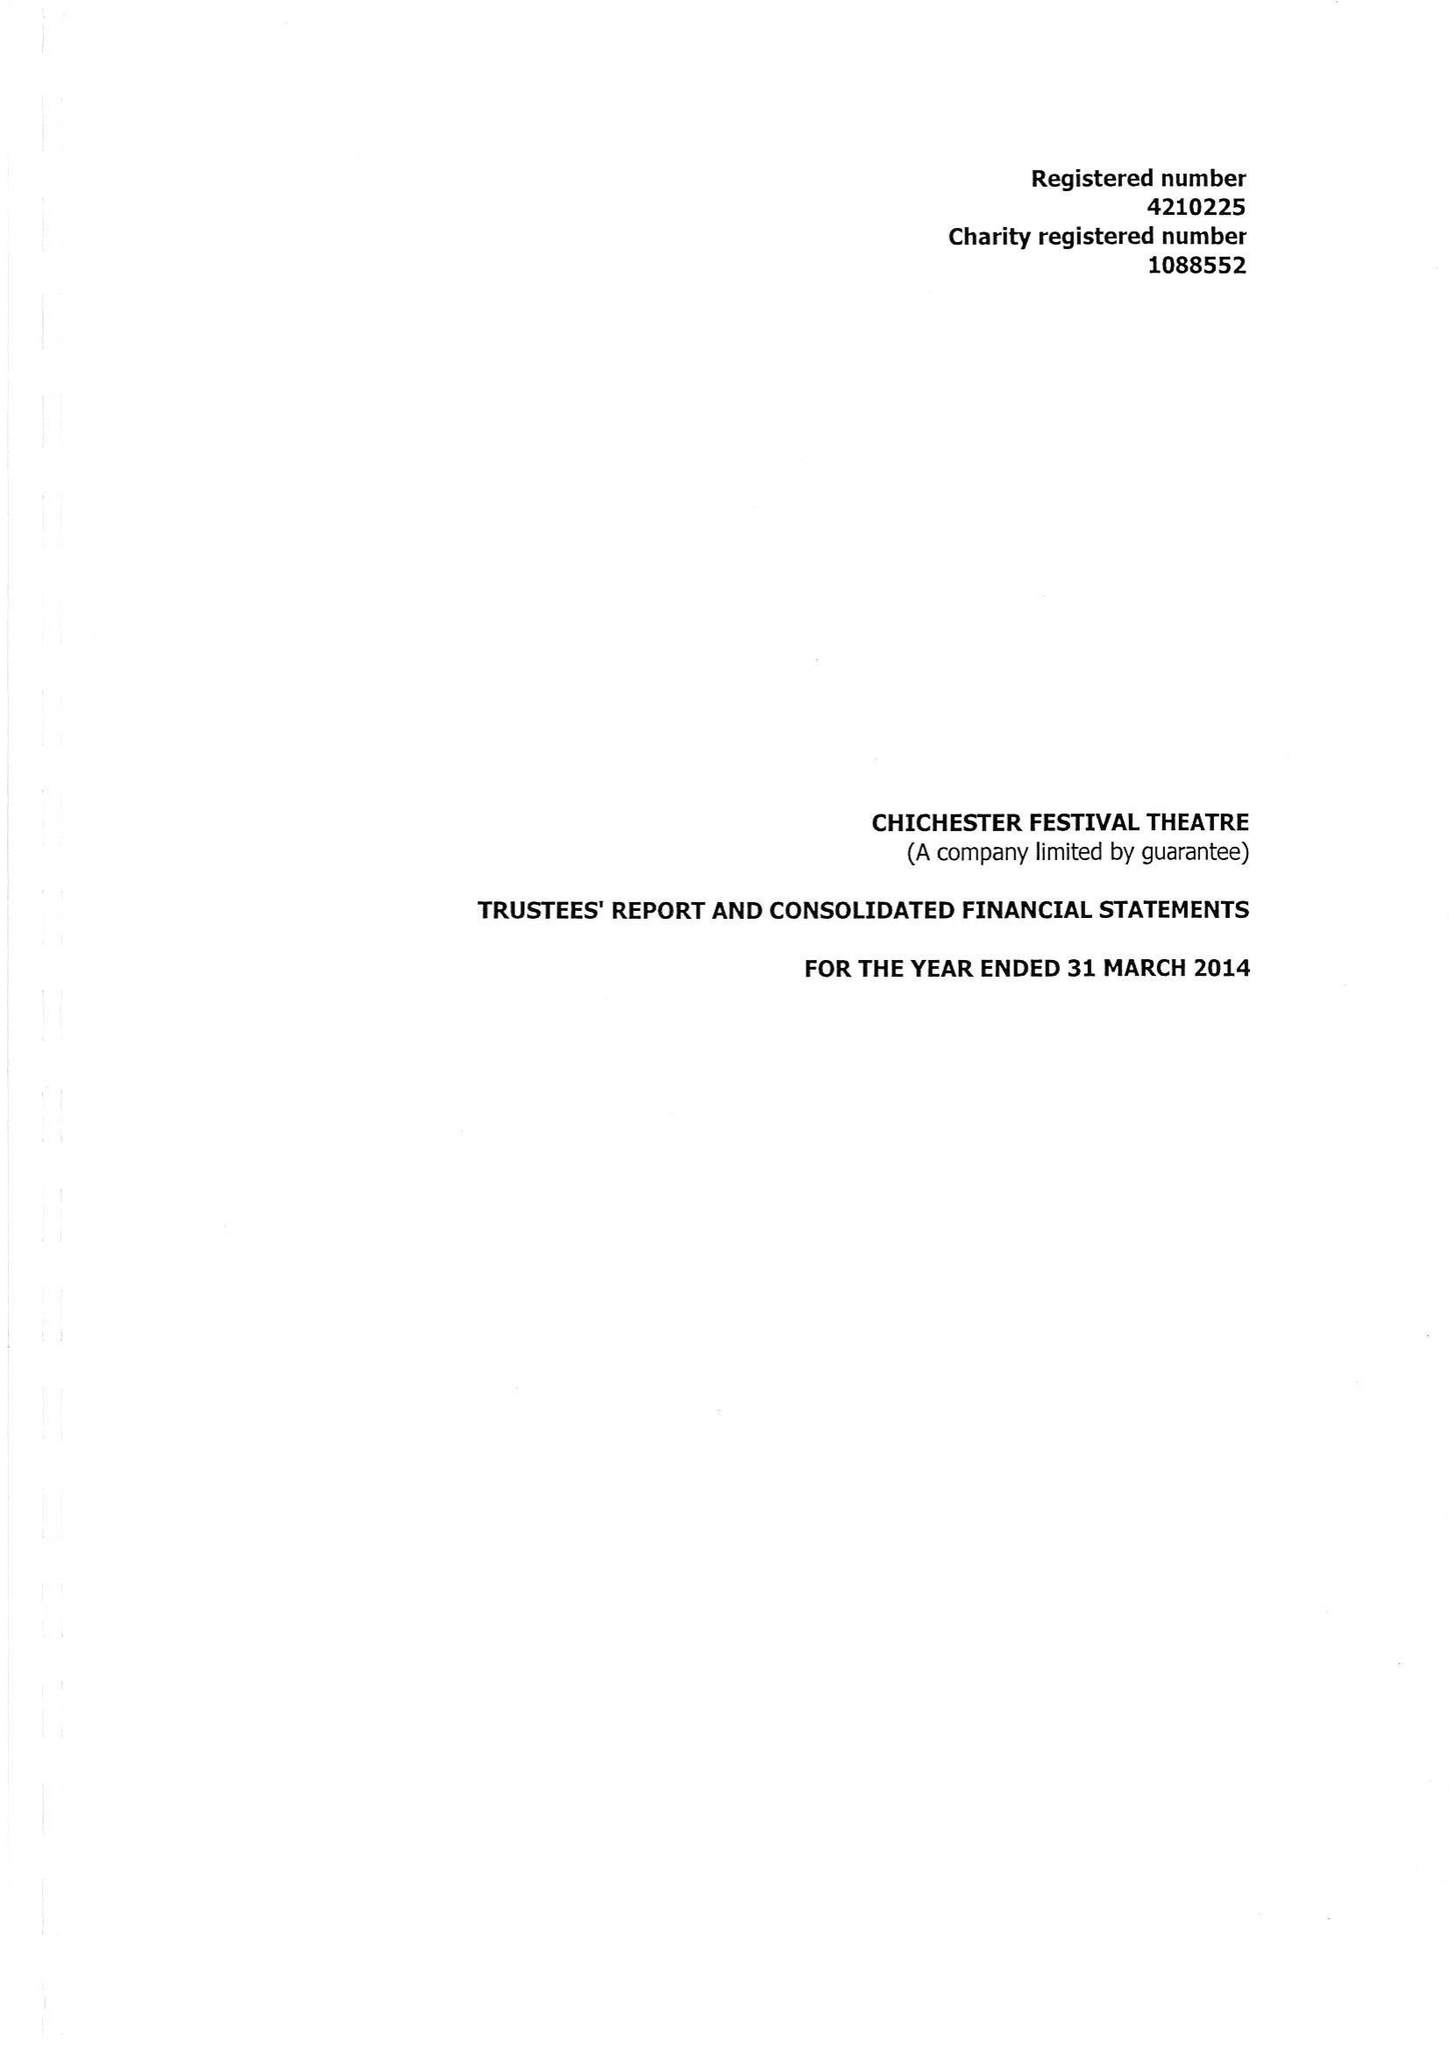What is the value for the charity_name?
Answer the question using a single word or phrase. Chichester Festival Theatre 